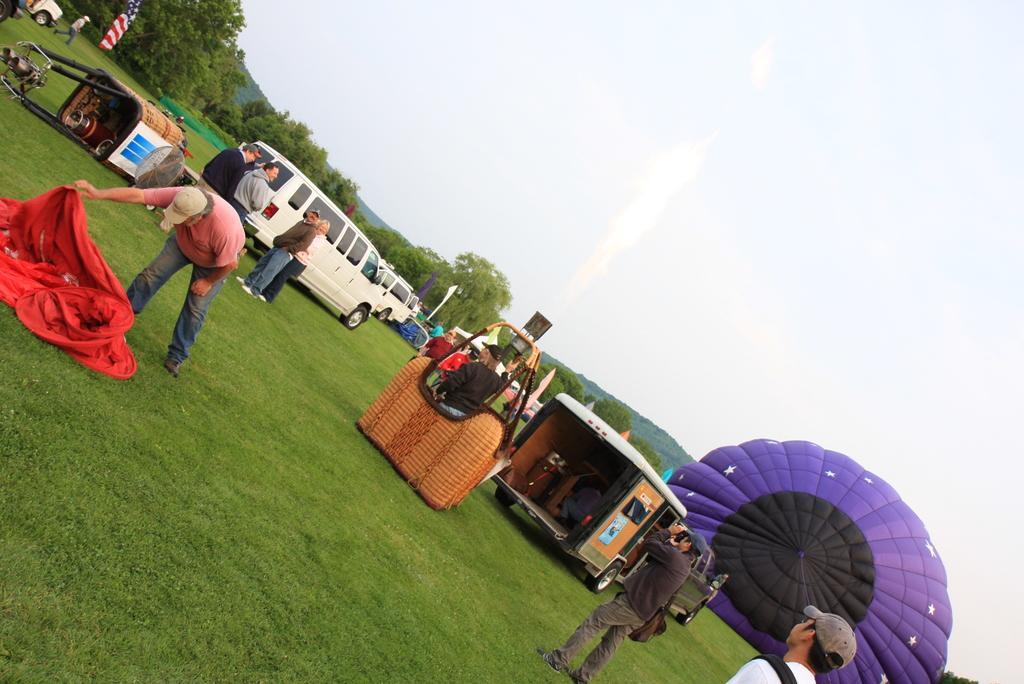How would you summarize this image in a sentence or two? This picture shows few vehicles parked and we see few people standing and we see couple of baskets and trees around and we see a parachute and a cloudy sky and we see a man holding a camera and taking picture. 